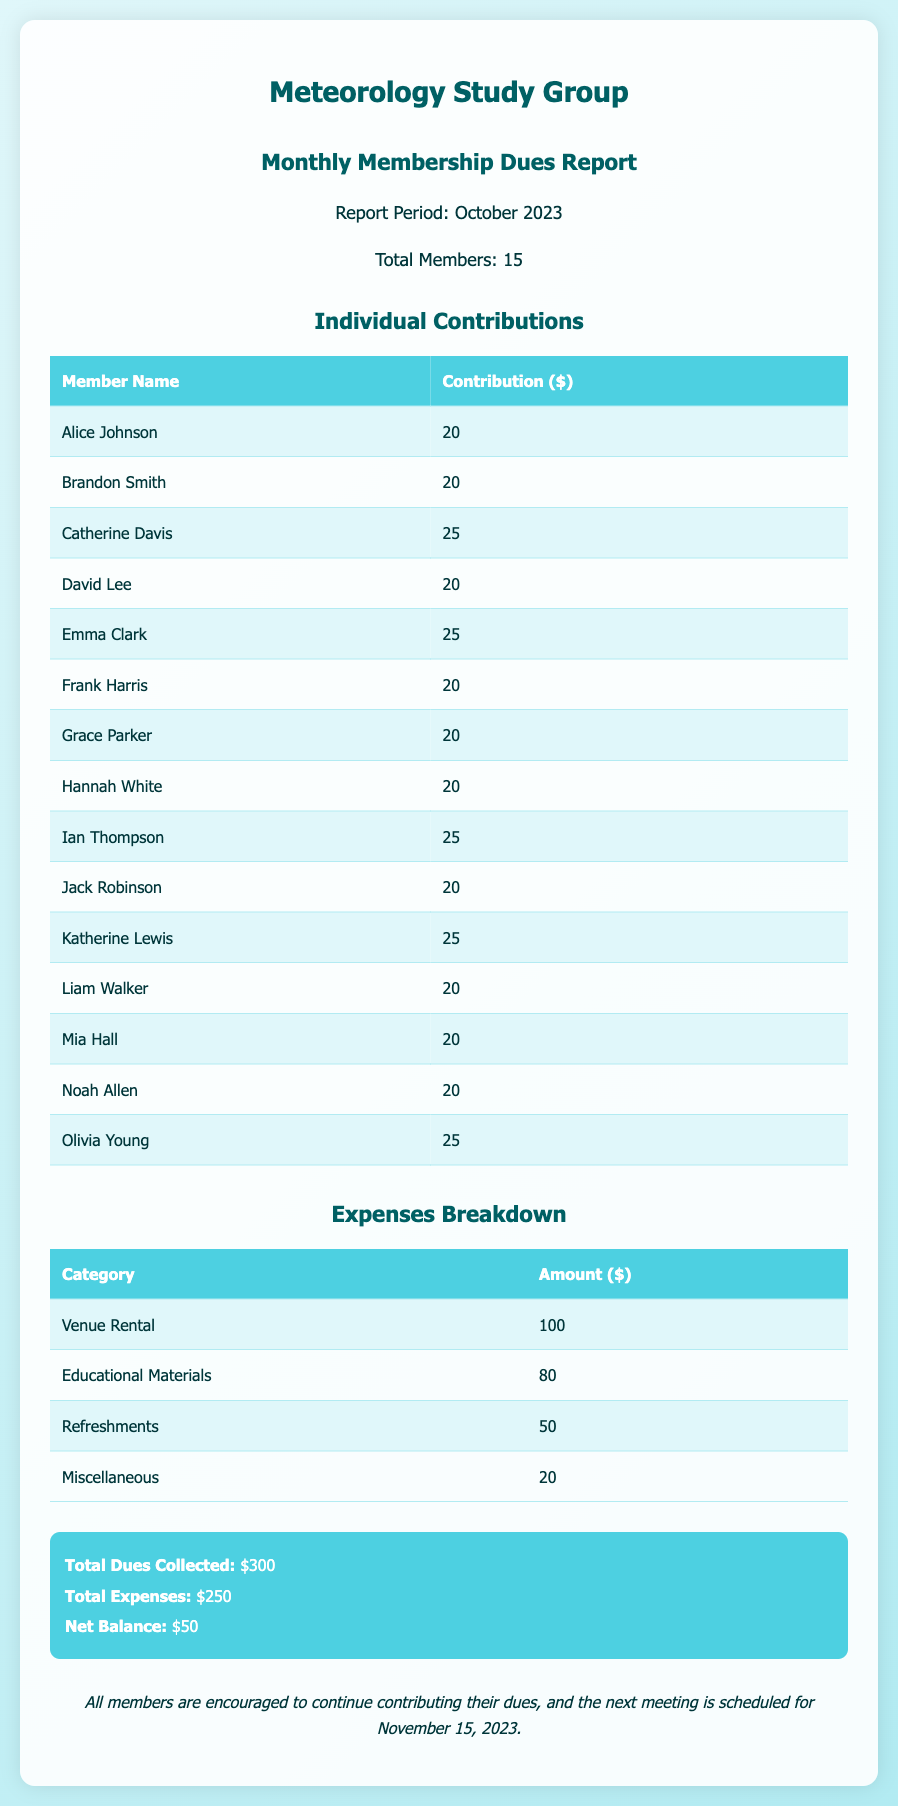What is the total number of members? The document states that the total number of members in the Meteorology Study Group is mentioned in the info section, which is 15.
Answer: 15 What is the highest individual contribution? The highest contribution among the members is found in the individual contributions table, where several members contributed $25.
Answer: 25 How much was collected in total dues? The total dues collected is summarized in the financial report, which is $300.
Answer: $300 What is the total amount spent on venue rental? The expenses breakdown shows that the venue rental cost is detailed in the expenses table, which is $100.
Answer: $100 What is the net balance calculated in the report? The net balance is calculated as total dues collected minus total expenses, which is detailed in the summary section, resulting in $50.
Answer: $50 How many categories of expenses are listed? The expenses breakdown section presents four different categories of expenses listed under the respective amounts.
Answer: 4 Who contributed the least amount? The individual contributions table indicates that multiple members contributed $20, which is the least amount in this context.
Answer: $20 What date is the next meeting scheduled for? The document includes a comment at the end, specifying when the next meeting is scheduled, which is November 15, 2023.
Answer: November 15, 2023 What is the total for educational materials? The expenses table line for educational materials shows that the amount spent is $80.
Answer: $80 